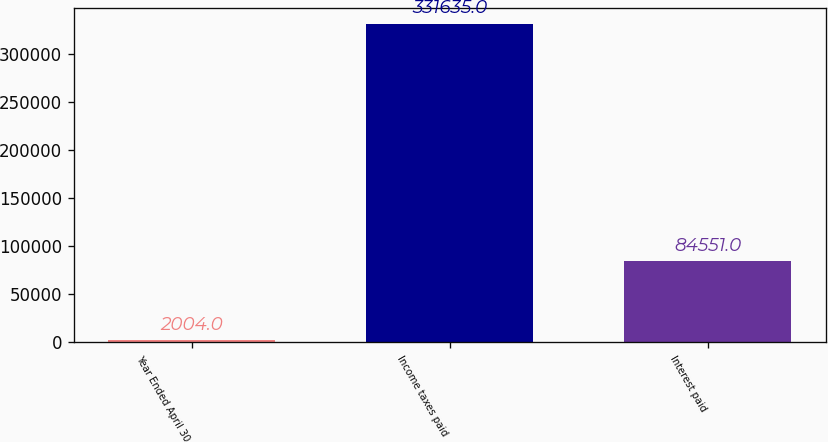<chart> <loc_0><loc_0><loc_500><loc_500><bar_chart><fcel>Year Ended April 30<fcel>Income taxes paid<fcel>Interest paid<nl><fcel>2004<fcel>331635<fcel>84551<nl></chart> 